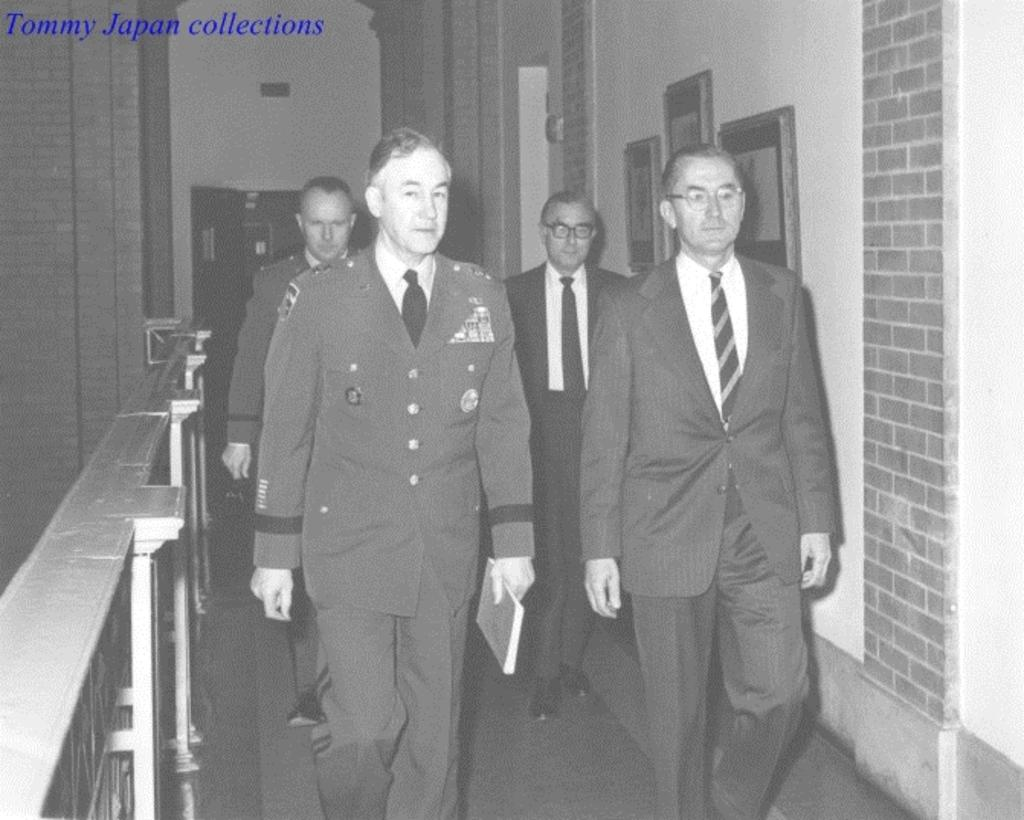What is the color scheme of the image? The image is black and white. How many people are in the image? There are four persons standing in the image. What can be seen on the wall in the image? There are frames attached to the wall in the image. Is there any additional information or marking on the image? Yes, there is a watermark on the image. Can you tell me what type of science experiment is being conducted by the woman in the image? There is no woman present in the image, nor is there any indication of a science experiment being conducted. 